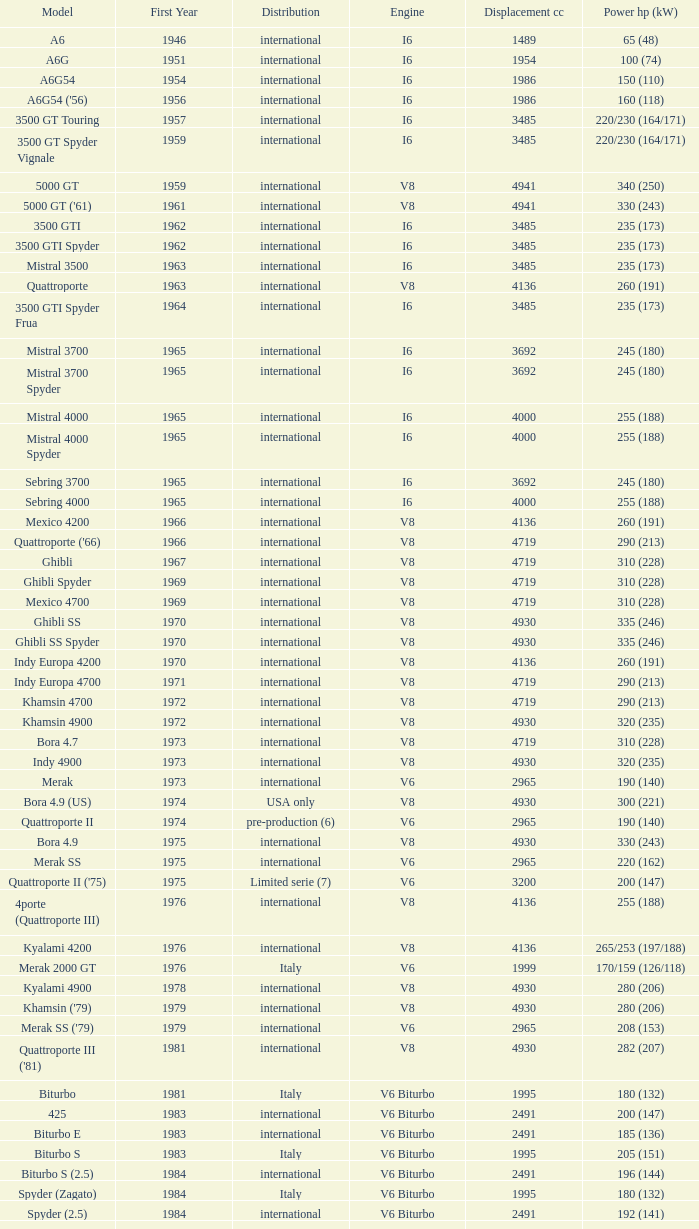What is the total count of first year when the displacement cc exceeds 4719, the engine is v8, the power hp (kw) is "335 (246)", and the model is "ghibli ss"? 1.0. 